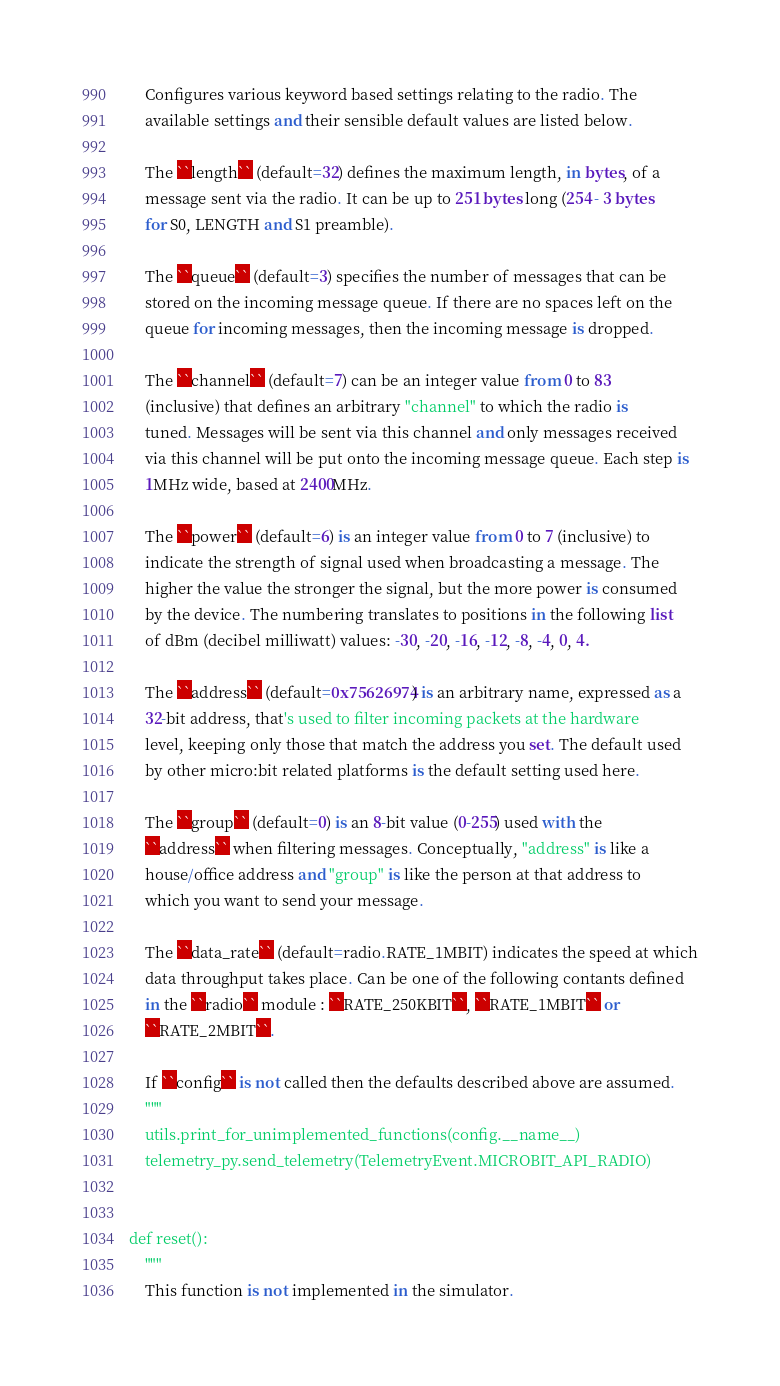<code> <loc_0><loc_0><loc_500><loc_500><_Python_>    Configures various keyword based settings relating to the radio. The
    available settings and their sensible default values are listed below.

    The ``length`` (default=32) defines the maximum length, in bytes, of a
    message sent via the radio. It can be up to 251 bytes long (254 - 3 bytes
    for S0, LENGTH and S1 preamble).

    The ``queue`` (default=3) specifies the number of messages that can be
    stored on the incoming message queue. If there are no spaces left on the
    queue for incoming messages, then the incoming message is dropped.

    The ``channel`` (default=7) can be an integer value from 0 to 83
    (inclusive) that defines an arbitrary "channel" to which the radio is
    tuned. Messages will be sent via this channel and only messages received
    via this channel will be put onto the incoming message queue. Each step is
    1MHz wide, based at 2400MHz.

    The ``power`` (default=6) is an integer value from 0 to 7 (inclusive) to
    indicate the strength of signal used when broadcasting a message. The
    higher the value the stronger the signal, but the more power is consumed
    by the device. The numbering translates to positions in the following list
    of dBm (decibel milliwatt) values: -30, -20, -16, -12, -8, -4, 0, 4.

    The ``address`` (default=0x75626974) is an arbitrary name, expressed as a
    32-bit address, that's used to filter incoming packets at the hardware
    level, keeping only those that match the address you set. The default used
    by other micro:bit related platforms is the default setting used here.

    The ``group`` (default=0) is an 8-bit value (0-255) used with the
    ``address`` when filtering messages. Conceptually, "address" is like a
    house/office address and "group" is like the person at that address to
    which you want to send your message.

    The ``data_rate`` (default=radio.RATE_1MBIT) indicates the speed at which
    data throughput takes place. Can be one of the following contants defined
    in the ``radio`` module : ``RATE_250KBIT``, ``RATE_1MBIT`` or
    ``RATE_2MBIT``.

    If ``config`` is not called then the defaults described above are assumed.
    """
    utils.print_for_unimplemented_functions(config.__name__)
    telemetry_py.send_telemetry(TelemetryEvent.MICROBIT_API_RADIO)


def reset():
    """
    This function is not implemented in the simulator.</code> 